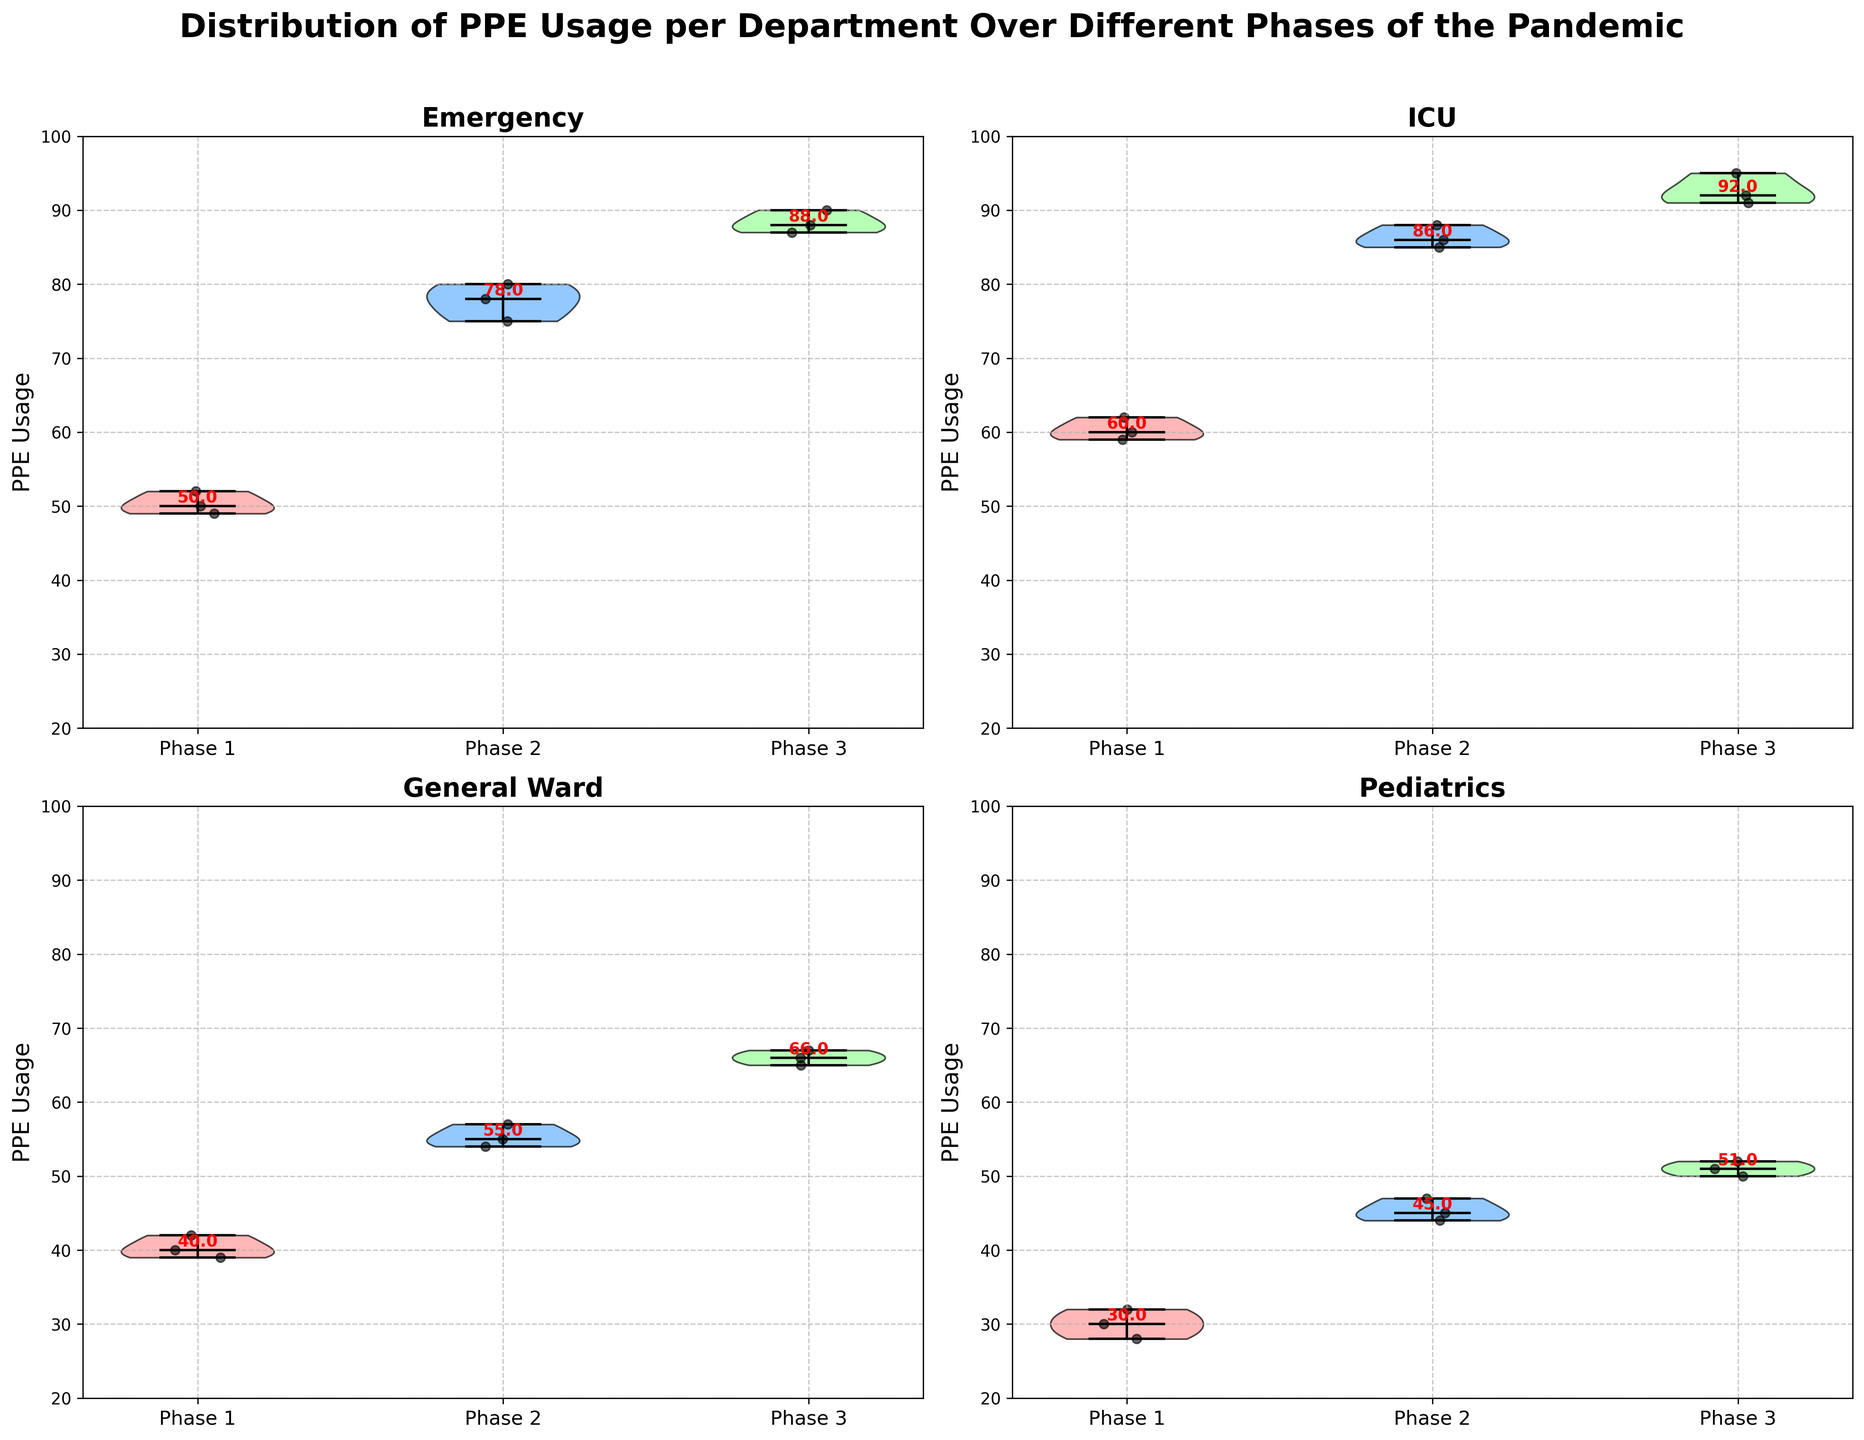How many departments are shown in the figure? The figure has individual violin plots for each department. By counting the subplots or department names, we see there are Emergency, ICU, General Ward, and Pediatrics.
Answer: 4 What's the title of the figure? The title is displayed at the top of the plot and is usually prominent. Here it reads "Distribution of PPE Usage per Department Over Different Phases of the Pandemic."
Answer: Distribution of PPE Usage per Department Over Different Phases of the Pandemic What is the median PPE usage in the ICU department during Phase 2? Check the violin plot for the ICU department and locate the red annotation for the median value in Phase 2.
Answer: 86 Which department has the highest median PPE usage in Phase 3? Compare the median values indicated in Phase 3 of each department's subplot. The ICU has the highest median at 92.
Answer: ICU Is there a phase where Pediatrics uses more PPE than General Ward? Compare the median values in all phases between Pediatrics and General Ward. Pediatrics' medians (Phase 3: 51) are all lower than General Ward's (Phase 1: 39, Phase 2: 54, Phase 3: 66).
Answer: No By how much did the median PPE usage in the Emergency department increase from Phase 1 to Phase 3? The median value in Phase 1 for Emergency is 50.5, and in Phase 3, it is approximately 88. The increase is 88 - 50.5 = 37.5.
Answer: 37.5 Which phase has the most consistent (least variability) PPE usage in the General Ward department? Look at the width of the violins in the General Ward subplot. Phase 3 has the least spread, indicating the most consistency.
Answer: Phase 3 Which department exhibited the biggest increase in PPE usage from Phase 1 to Phase 2? By checking the median values of Phase 1 and Phase 2 for each department, Pediatrics increased from 30 to 45, which is the largest change of 15 units.
Answer: Pediatrics What is the range of PPE usage in the Emergency department during Phase 2? Assess the minimum and maximum points of the violin plot for Emergency in Phase 2. The range is from 75 to 80.
Answer: 75-80 How does the variability of PPE usage in ICU compare between Phase 1 and Phase 3? Observe the width and spread of the violins for ICU in both phases. Phase 1 is narrower than Phase 3, indicating less variability.
Answer: ICU in Phase 1 is less variable than in Phase 3 